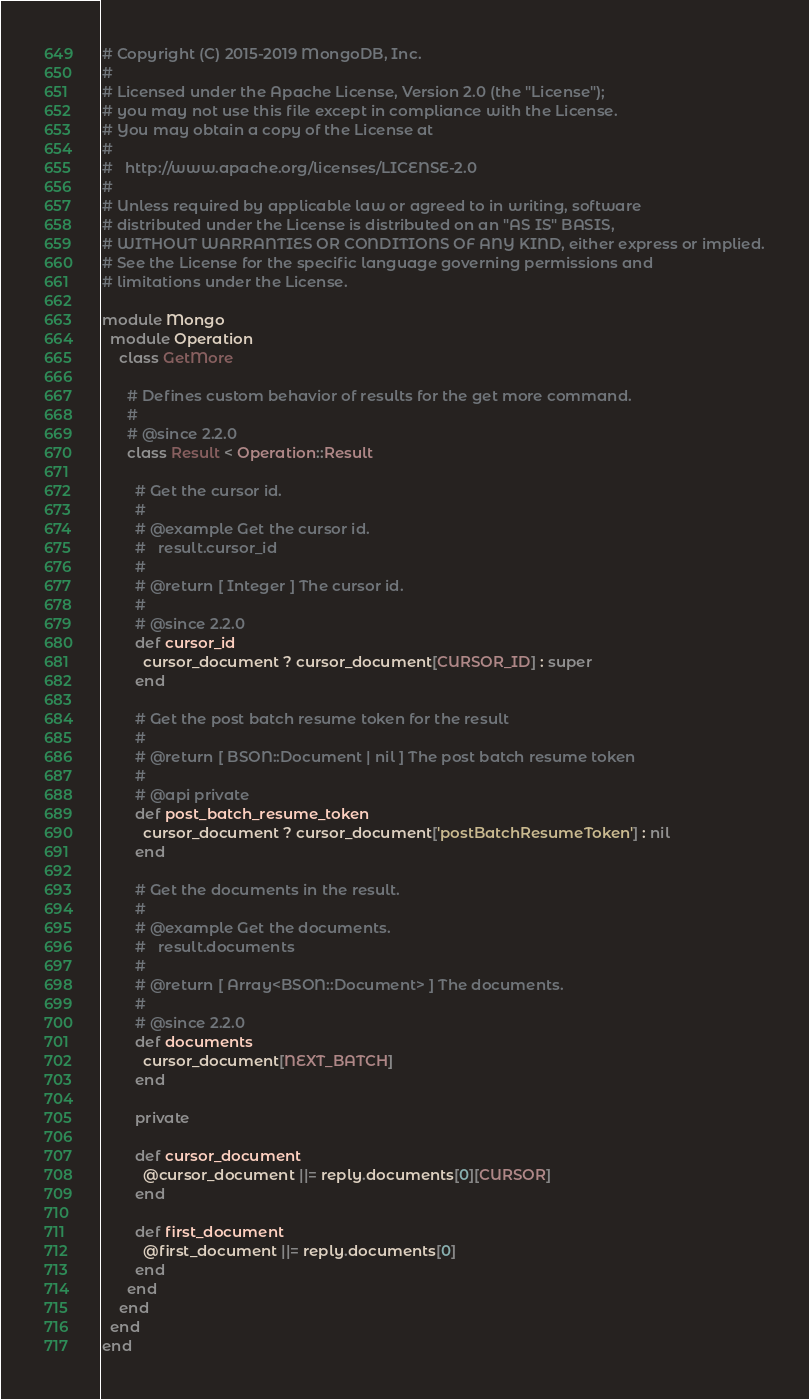Convert code to text. <code><loc_0><loc_0><loc_500><loc_500><_Ruby_># Copyright (C) 2015-2019 MongoDB, Inc.
#
# Licensed under the Apache License, Version 2.0 (the "License");
# you may not use this file except in compliance with the License.
# You may obtain a copy of the License at
#
#   http://www.apache.org/licenses/LICENSE-2.0
#
# Unless required by applicable law or agreed to in writing, software
# distributed under the License is distributed on an "AS IS" BASIS,
# WITHOUT WARRANTIES OR CONDITIONS OF ANY KIND, either express or implied.
# See the License for the specific language governing permissions and
# limitations under the License.

module Mongo
  module Operation
    class GetMore

      # Defines custom behavior of results for the get more command.
      #
      # @since 2.2.0
      class Result < Operation::Result

        # Get the cursor id.
        #
        # @example Get the cursor id.
        #   result.cursor_id
        #
        # @return [ Integer ] The cursor id.
        #
        # @since 2.2.0
        def cursor_id
          cursor_document ? cursor_document[CURSOR_ID] : super
        end

        # Get the post batch resume token for the result
        #
        # @return [ BSON::Document | nil ] The post batch resume token
        #
        # @api private
        def post_batch_resume_token
          cursor_document ? cursor_document['postBatchResumeToken'] : nil
        end

        # Get the documents in the result.
        #
        # @example Get the documents.
        #   result.documents
        #
        # @return [ Array<BSON::Document> ] The documents.
        #
        # @since 2.2.0
        def documents
          cursor_document[NEXT_BATCH]
        end

        private

        def cursor_document
          @cursor_document ||= reply.documents[0][CURSOR]
        end

        def first_document
          @first_document ||= reply.documents[0]
        end
      end
    end
  end
end
</code> 